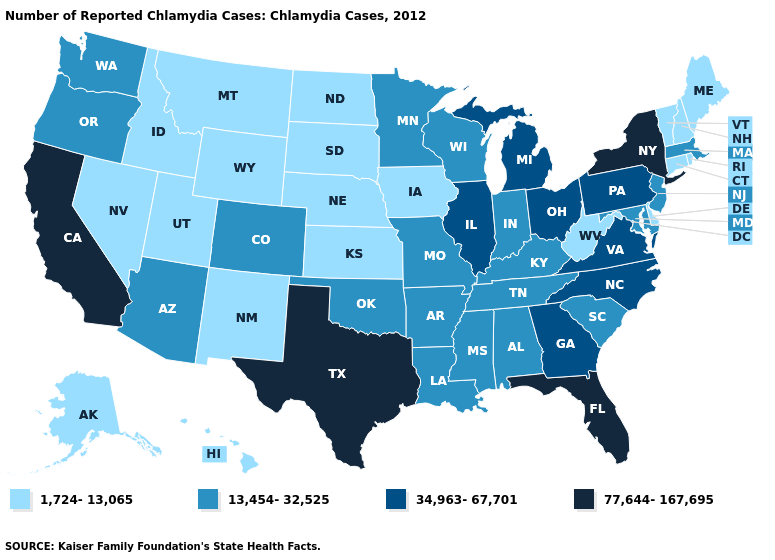Which states have the lowest value in the USA?
Quick response, please. Alaska, Connecticut, Delaware, Hawaii, Idaho, Iowa, Kansas, Maine, Montana, Nebraska, Nevada, New Hampshire, New Mexico, North Dakota, Rhode Island, South Dakota, Utah, Vermont, West Virginia, Wyoming. What is the value of West Virginia?
Keep it brief. 1,724-13,065. What is the value of Wisconsin?
Give a very brief answer. 13,454-32,525. Does Florida have the lowest value in the USA?
Quick response, please. No. Among the states that border Idaho , which have the lowest value?
Quick response, please. Montana, Nevada, Utah, Wyoming. What is the value of Arkansas?
Concise answer only. 13,454-32,525. What is the highest value in the West ?
Be succinct. 77,644-167,695. Name the states that have a value in the range 77,644-167,695?
Quick response, please. California, Florida, New York, Texas. Does Oklahoma have the lowest value in the USA?
Keep it brief. No. What is the lowest value in states that border New York?
Write a very short answer. 1,724-13,065. Name the states that have a value in the range 1,724-13,065?
Quick response, please. Alaska, Connecticut, Delaware, Hawaii, Idaho, Iowa, Kansas, Maine, Montana, Nebraska, Nevada, New Hampshire, New Mexico, North Dakota, Rhode Island, South Dakota, Utah, Vermont, West Virginia, Wyoming. What is the value of Indiana?
Be succinct. 13,454-32,525. What is the value of New Mexico?
Be succinct. 1,724-13,065. What is the value of Iowa?
Give a very brief answer. 1,724-13,065. What is the highest value in the USA?
Answer briefly. 77,644-167,695. 